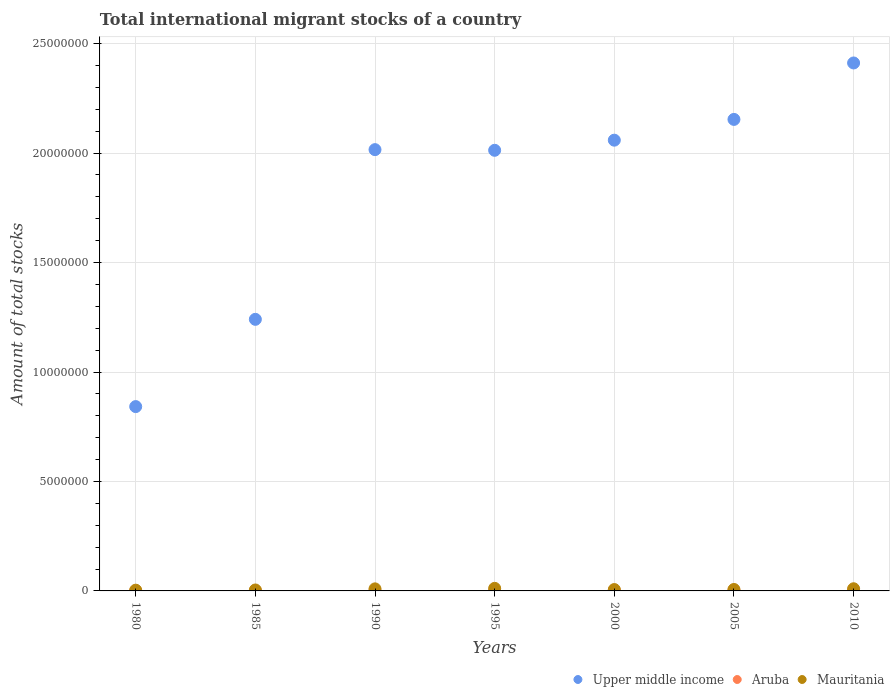Is the number of dotlines equal to the number of legend labels?
Provide a short and direct response. Yes. What is the amount of total stocks in in Aruba in 2010?
Offer a very short reply. 3.43e+04. Across all years, what is the maximum amount of total stocks in in Mauritania?
Give a very brief answer. 1.18e+05. Across all years, what is the minimum amount of total stocks in in Upper middle income?
Make the answer very short. 8.42e+06. In which year was the amount of total stocks in in Aruba minimum?
Keep it short and to the point. 1980. What is the total amount of total stocks in in Aruba in the graph?
Your response must be concise. 1.49e+05. What is the difference between the amount of total stocks in in Upper middle income in 1990 and that in 2000?
Offer a very short reply. -4.32e+05. What is the difference between the amount of total stocks in in Mauritania in 2000 and the amount of total stocks in in Aruba in 1980?
Your answer should be compact. 5.55e+04. What is the average amount of total stocks in in Aruba per year?
Provide a short and direct response. 2.13e+04. In the year 2000, what is the difference between the amount of total stocks in in Mauritania and amount of total stocks in in Aruba?
Provide a short and direct response. 3.31e+04. What is the ratio of the amount of total stocks in in Aruba in 1985 to that in 1990?
Keep it short and to the point. 0.68. Is the amount of total stocks in in Aruba in 1980 less than that in 1995?
Keep it short and to the point. Yes. Is the difference between the amount of total stocks in in Mauritania in 1985 and 1995 greater than the difference between the amount of total stocks in in Aruba in 1985 and 1995?
Provide a short and direct response. No. What is the difference between the highest and the second highest amount of total stocks in in Aruba?
Provide a succinct answer. 846. What is the difference between the highest and the lowest amount of total stocks in in Upper middle income?
Give a very brief answer. 1.57e+07. In how many years, is the amount of total stocks in in Aruba greater than the average amount of total stocks in in Aruba taken over all years?
Give a very brief answer. 3. Is it the case that in every year, the sum of the amount of total stocks in in Mauritania and amount of total stocks in in Upper middle income  is greater than the amount of total stocks in in Aruba?
Your answer should be compact. Yes. Does the amount of total stocks in in Aruba monotonically increase over the years?
Provide a short and direct response. Yes. Is the amount of total stocks in in Mauritania strictly greater than the amount of total stocks in in Upper middle income over the years?
Your answer should be compact. No. Is the amount of total stocks in in Aruba strictly less than the amount of total stocks in in Upper middle income over the years?
Give a very brief answer. Yes. How many dotlines are there?
Ensure brevity in your answer.  3. How many years are there in the graph?
Ensure brevity in your answer.  7. What is the difference between two consecutive major ticks on the Y-axis?
Ensure brevity in your answer.  5.00e+06. Are the values on the major ticks of Y-axis written in scientific E-notation?
Give a very brief answer. No. Does the graph contain any zero values?
Your answer should be compact. No. Does the graph contain grids?
Give a very brief answer. Yes. Where does the legend appear in the graph?
Offer a very short reply. Bottom right. What is the title of the graph?
Offer a very short reply. Total international migrant stocks of a country. Does "San Marino" appear as one of the legend labels in the graph?
Your response must be concise. No. What is the label or title of the Y-axis?
Offer a terse response. Amount of total stocks. What is the Amount of total stocks of Upper middle income in 1980?
Ensure brevity in your answer.  8.42e+06. What is the Amount of total stocks in Aruba in 1980?
Make the answer very short. 7063. What is the Amount of total stocks of Mauritania in 1980?
Offer a terse response. 3.37e+04. What is the Amount of total stocks in Upper middle income in 1985?
Keep it short and to the point. 1.24e+07. What is the Amount of total stocks of Aruba in 1985?
Keep it short and to the point. 9860. What is the Amount of total stocks in Mauritania in 1985?
Your answer should be very brief. 4.36e+04. What is the Amount of total stocks of Upper middle income in 1990?
Keep it short and to the point. 2.02e+07. What is the Amount of total stocks of Aruba in 1990?
Give a very brief answer. 1.44e+04. What is the Amount of total stocks in Mauritania in 1990?
Keep it short and to the point. 9.39e+04. What is the Amount of total stocks in Upper middle income in 1995?
Ensure brevity in your answer.  2.01e+07. What is the Amount of total stocks of Aruba in 1995?
Ensure brevity in your answer.  2.07e+04. What is the Amount of total stocks of Mauritania in 1995?
Provide a short and direct response. 1.18e+05. What is the Amount of total stocks in Upper middle income in 2000?
Provide a succinct answer. 2.06e+07. What is the Amount of total stocks in Aruba in 2000?
Provide a succinct answer. 2.95e+04. What is the Amount of total stocks of Mauritania in 2000?
Offer a very short reply. 6.26e+04. What is the Amount of total stocks of Upper middle income in 2005?
Provide a short and direct response. 2.15e+07. What is the Amount of total stocks in Aruba in 2005?
Your answer should be compact. 3.34e+04. What is the Amount of total stocks of Mauritania in 2005?
Provide a succinct answer. 6.61e+04. What is the Amount of total stocks in Upper middle income in 2010?
Keep it short and to the point. 2.41e+07. What is the Amount of total stocks of Aruba in 2010?
Offer a terse response. 3.43e+04. What is the Amount of total stocks of Mauritania in 2010?
Ensure brevity in your answer.  9.92e+04. Across all years, what is the maximum Amount of total stocks of Upper middle income?
Make the answer very short. 2.41e+07. Across all years, what is the maximum Amount of total stocks in Aruba?
Ensure brevity in your answer.  3.43e+04. Across all years, what is the maximum Amount of total stocks in Mauritania?
Make the answer very short. 1.18e+05. Across all years, what is the minimum Amount of total stocks of Upper middle income?
Provide a succinct answer. 8.42e+06. Across all years, what is the minimum Amount of total stocks of Aruba?
Your answer should be compact. 7063. Across all years, what is the minimum Amount of total stocks in Mauritania?
Keep it short and to the point. 3.37e+04. What is the total Amount of total stocks in Upper middle income in the graph?
Ensure brevity in your answer.  1.27e+08. What is the total Amount of total stocks in Aruba in the graph?
Keep it short and to the point. 1.49e+05. What is the total Amount of total stocks of Mauritania in the graph?
Make the answer very short. 5.17e+05. What is the difference between the Amount of total stocks of Upper middle income in 1980 and that in 1985?
Give a very brief answer. -3.99e+06. What is the difference between the Amount of total stocks in Aruba in 1980 and that in 1985?
Offer a very short reply. -2797. What is the difference between the Amount of total stocks in Mauritania in 1980 and that in 1985?
Your response must be concise. -9883. What is the difference between the Amount of total stocks of Upper middle income in 1980 and that in 1990?
Offer a very short reply. -1.17e+07. What is the difference between the Amount of total stocks of Aruba in 1980 and that in 1990?
Give a very brief answer. -7381. What is the difference between the Amount of total stocks in Mauritania in 1980 and that in 1990?
Your answer should be very brief. -6.02e+04. What is the difference between the Amount of total stocks in Upper middle income in 1980 and that in 1995?
Offer a very short reply. -1.17e+07. What is the difference between the Amount of total stocks in Aruba in 1980 and that in 1995?
Your response must be concise. -1.37e+04. What is the difference between the Amount of total stocks of Mauritania in 1980 and that in 1995?
Your response must be concise. -8.39e+04. What is the difference between the Amount of total stocks in Upper middle income in 1980 and that in 2000?
Provide a succinct answer. -1.22e+07. What is the difference between the Amount of total stocks in Aruba in 1980 and that in 2000?
Your answer should be very brief. -2.24e+04. What is the difference between the Amount of total stocks of Mauritania in 1980 and that in 2000?
Your answer should be compact. -2.89e+04. What is the difference between the Amount of total stocks of Upper middle income in 1980 and that in 2005?
Your answer should be very brief. -1.31e+07. What is the difference between the Amount of total stocks of Aruba in 1980 and that in 2005?
Your answer should be compact. -2.64e+04. What is the difference between the Amount of total stocks in Mauritania in 1980 and that in 2005?
Offer a terse response. -3.23e+04. What is the difference between the Amount of total stocks in Upper middle income in 1980 and that in 2010?
Ensure brevity in your answer.  -1.57e+07. What is the difference between the Amount of total stocks of Aruba in 1980 and that in 2010?
Make the answer very short. -2.72e+04. What is the difference between the Amount of total stocks of Mauritania in 1980 and that in 2010?
Make the answer very short. -6.55e+04. What is the difference between the Amount of total stocks of Upper middle income in 1985 and that in 1990?
Keep it short and to the point. -7.75e+06. What is the difference between the Amount of total stocks of Aruba in 1985 and that in 1990?
Offer a terse response. -4584. What is the difference between the Amount of total stocks in Mauritania in 1985 and that in 1990?
Your answer should be compact. -5.03e+04. What is the difference between the Amount of total stocks of Upper middle income in 1985 and that in 1995?
Offer a very short reply. -7.72e+06. What is the difference between the Amount of total stocks of Aruba in 1985 and that in 1995?
Provide a succinct answer. -1.09e+04. What is the difference between the Amount of total stocks in Mauritania in 1985 and that in 1995?
Give a very brief answer. -7.40e+04. What is the difference between the Amount of total stocks of Upper middle income in 1985 and that in 2000?
Your answer should be very brief. -8.18e+06. What is the difference between the Amount of total stocks of Aruba in 1985 and that in 2000?
Offer a terse response. -1.96e+04. What is the difference between the Amount of total stocks in Mauritania in 1985 and that in 2000?
Make the answer very short. -1.90e+04. What is the difference between the Amount of total stocks of Upper middle income in 1985 and that in 2005?
Your answer should be very brief. -9.13e+06. What is the difference between the Amount of total stocks of Aruba in 1985 and that in 2005?
Make the answer very short. -2.36e+04. What is the difference between the Amount of total stocks of Mauritania in 1985 and that in 2005?
Provide a succinct answer. -2.25e+04. What is the difference between the Amount of total stocks in Upper middle income in 1985 and that in 2010?
Offer a terse response. -1.17e+07. What is the difference between the Amount of total stocks in Aruba in 1985 and that in 2010?
Keep it short and to the point. -2.44e+04. What is the difference between the Amount of total stocks in Mauritania in 1985 and that in 2010?
Your response must be concise. -5.56e+04. What is the difference between the Amount of total stocks in Upper middle income in 1990 and that in 1995?
Your answer should be compact. 3.02e+04. What is the difference between the Amount of total stocks in Aruba in 1990 and that in 1995?
Your answer should be compact. -6271. What is the difference between the Amount of total stocks in Mauritania in 1990 and that in 1995?
Provide a short and direct response. -2.37e+04. What is the difference between the Amount of total stocks in Upper middle income in 1990 and that in 2000?
Ensure brevity in your answer.  -4.32e+05. What is the difference between the Amount of total stocks of Aruba in 1990 and that in 2000?
Your answer should be compact. -1.51e+04. What is the difference between the Amount of total stocks in Mauritania in 1990 and that in 2000?
Provide a succinct answer. 3.13e+04. What is the difference between the Amount of total stocks in Upper middle income in 1990 and that in 2005?
Offer a terse response. -1.38e+06. What is the difference between the Amount of total stocks of Aruba in 1990 and that in 2005?
Your response must be concise. -1.90e+04. What is the difference between the Amount of total stocks in Mauritania in 1990 and that in 2005?
Provide a short and direct response. 2.78e+04. What is the difference between the Amount of total stocks of Upper middle income in 1990 and that in 2010?
Make the answer very short. -3.96e+06. What is the difference between the Amount of total stocks of Aruba in 1990 and that in 2010?
Ensure brevity in your answer.  -1.98e+04. What is the difference between the Amount of total stocks in Mauritania in 1990 and that in 2010?
Offer a terse response. -5351. What is the difference between the Amount of total stocks in Upper middle income in 1995 and that in 2000?
Give a very brief answer. -4.63e+05. What is the difference between the Amount of total stocks in Aruba in 1995 and that in 2000?
Ensure brevity in your answer.  -8780. What is the difference between the Amount of total stocks in Mauritania in 1995 and that in 2000?
Offer a very short reply. 5.50e+04. What is the difference between the Amount of total stocks of Upper middle income in 1995 and that in 2005?
Keep it short and to the point. -1.41e+06. What is the difference between the Amount of total stocks of Aruba in 1995 and that in 2005?
Provide a succinct answer. -1.27e+04. What is the difference between the Amount of total stocks in Mauritania in 1995 and that in 2005?
Your answer should be very brief. 5.15e+04. What is the difference between the Amount of total stocks in Upper middle income in 1995 and that in 2010?
Your answer should be very brief. -3.99e+06. What is the difference between the Amount of total stocks of Aruba in 1995 and that in 2010?
Offer a very short reply. -1.36e+04. What is the difference between the Amount of total stocks in Mauritania in 1995 and that in 2010?
Ensure brevity in your answer.  1.84e+04. What is the difference between the Amount of total stocks of Upper middle income in 2000 and that in 2005?
Offer a very short reply. -9.49e+05. What is the difference between the Amount of total stocks in Aruba in 2000 and that in 2005?
Offer a terse response. -3927. What is the difference between the Amount of total stocks of Mauritania in 2000 and that in 2005?
Make the answer very short. -3460. What is the difference between the Amount of total stocks in Upper middle income in 2000 and that in 2010?
Offer a terse response. -3.53e+06. What is the difference between the Amount of total stocks in Aruba in 2000 and that in 2010?
Your answer should be compact. -4773. What is the difference between the Amount of total stocks in Mauritania in 2000 and that in 2010?
Make the answer very short. -3.66e+04. What is the difference between the Amount of total stocks in Upper middle income in 2005 and that in 2010?
Ensure brevity in your answer.  -2.58e+06. What is the difference between the Amount of total stocks in Aruba in 2005 and that in 2010?
Make the answer very short. -846. What is the difference between the Amount of total stocks in Mauritania in 2005 and that in 2010?
Your response must be concise. -3.32e+04. What is the difference between the Amount of total stocks in Upper middle income in 1980 and the Amount of total stocks in Aruba in 1985?
Your answer should be compact. 8.41e+06. What is the difference between the Amount of total stocks in Upper middle income in 1980 and the Amount of total stocks in Mauritania in 1985?
Your answer should be very brief. 8.38e+06. What is the difference between the Amount of total stocks of Aruba in 1980 and the Amount of total stocks of Mauritania in 1985?
Offer a terse response. -3.65e+04. What is the difference between the Amount of total stocks of Upper middle income in 1980 and the Amount of total stocks of Aruba in 1990?
Your answer should be very brief. 8.41e+06. What is the difference between the Amount of total stocks of Upper middle income in 1980 and the Amount of total stocks of Mauritania in 1990?
Keep it short and to the point. 8.33e+06. What is the difference between the Amount of total stocks in Aruba in 1980 and the Amount of total stocks in Mauritania in 1990?
Keep it short and to the point. -8.68e+04. What is the difference between the Amount of total stocks in Upper middle income in 1980 and the Amount of total stocks in Aruba in 1995?
Give a very brief answer. 8.40e+06. What is the difference between the Amount of total stocks of Upper middle income in 1980 and the Amount of total stocks of Mauritania in 1995?
Provide a short and direct response. 8.30e+06. What is the difference between the Amount of total stocks in Aruba in 1980 and the Amount of total stocks in Mauritania in 1995?
Make the answer very short. -1.11e+05. What is the difference between the Amount of total stocks in Upper middle income in 1980 and the Amount of total stocks in Aruba in 2000?
Make the answer very short. 8.39e+06. What is the difference between the Amount of total stocks of Upper middle income in 1980 and the Amount of total stocks of Mauritania in 2000?
Offer a very short reply. 8.36e+06. What is the difference between the Amount of total stocks in Aruba in 1980 and the Amount of total stocks in Mauritania in 2000?
Your response must be concise. -5.55e+04. What is the difference between the Amount of total stocks in Upper middle income in 1980 and the Amount of total stocks in Aruba in 2005?
Make the answer very short. 8.39e+06. What is the difference between the Amount of total stocks of Upper middle income in 1980 and the Amount of total stocks of Mauritania in 2005?
Keep it short and to the point. 8.35e+06. What is the difference between the Amount of total stocks in Aruba in 1980 and the Amount of total stocks in Mauritania in 2005?
Offer a terse response. -5.90e+04. What is the difference between the Amount of total stocks of Upper middle income in 1980 and the Amount of total stocks of Aruba in 2010?
Make the answer very short. 8.39e+06. What is the difference between the Amount of total stocks in Upper middle income in 1980 and the Amount of total stocks in Mauritania in 2010?
Offer a very short reply. 8.32e+06. What is the difference between the Amount of total stocks in Aruba in 1980 and the Amount of total stocks in Mauritania in 2010?
Provide a succinct answer. -9.22e+04. What is the difference between the Amount of total stocks of Upper middle income in 1985 and the Amount of total stocks of Aruba in 1990?
Offer a very short reply. 1.24e+07. What is the difference between the Amount of total stocks of Upper middle income in 1985 and the Amount of total stocks of Mauritania in 1990?
Your answer should be compact. 1.23e+07. What is the difference between the Amount of total stocks of Aruba in 1985 and the Amount of total stocks of Mauritania in 1990?
Offer a terse response. -8.40e+04. What is the difference between the Amount of total stocks in Upper middle income in 1985 and the Amount of total stocks in Aruba in 1995?
Your answer should be compact. 1.24e+07. What is the difference between the Amount of total stocks of Upper middle income in 1985 and the Amount of total stocks of Mauritania in 1995?
Provide a succinct answer. 1.23e+07. What is the difference between the Amount of total stocks in Aruba in 1985 and the Amount of total stocks in Mauritania in 1995?
Your answer should be compact. -1.08e+05. What is the difference between the Amount of total stocks in Upper middle income in 1985 and the Amount of total stocks in Aruba in 2000?
Ensure brevity in your answer.  1.24e+07. What is the difference between the Amount of total stocks in Upper middle income in 1985 and the Amount of total stocks in Mauritania in 2000?
Your response must be concise. 1.23e+07. What is the difference between the Amount of total stocks of Aruba in 1985 and the Amount of total stocks of Mauritania in 2000?
Offer a terse response. -5.27e+04. What is the difference between the Amount of total stocks in Upper middle income in 1985 and the Amount of total stocks in Aruba in 2005?
Give a very brief answer. 1.24e+07. What is the difference between the Amount of total stocks of Upper middle income in 1985 and the Amount of total stocks of Mauritania in 2005?
Give a very brief answer. 1.23e+07. What is the difference between the Amount of total stocks in Aruba in 1985 and the Amount of total stocks in Mauritania in 2005?
Provide a short and direct response. -5.62e+04. What is the difference between the Amount of total stocks of Upper middle income in 1985 and the Amount of total stocks of Aruba in 2010?
Give a very brief answer. 1.24e+07. What is the difference between the Amount of total stocks in Upper middle income in 1985 and the Amount of total stocks in Mauritania in 2010?
Make the answer very short. 1.23e+07. What is the difference between the Amount of total stocks of Aruba in 1985 and the Amount of total stocks of Mauritania in 2010?
Provide a short and direct response. -8.94e+04. What is the difference between the Amount of total stocks of Upper middle income in 1990 and the Amount of total stocks of Aruba in 1995?
Your answer should be very brief. 2.01e+07. What is the difference between the Amount of total stocks in Upper middle income in 1990 and the Amount of total stocks in Mauritania in 1995?
Ensure brevity in your answer.  2.00e+07. What is the difference between the Amount of total stocks in Aruba in 1990 and the Amount of total stocks in Mauritania in 1995?
Keep it short and to the point. -1.03e+05. What is the difference between the Amount of total stocks of Upper middle income in 1990 and the Amount of total stocks of Aruba in 2000?
Keep it short and to the point. 2.01e+07. What is the difference between the Amount of total stocks in Upper middle income in 1990 and the Amount of total stocks in Mauritania in 2000?
Make the answer very short. 2.01e+07. What is the difference between the Amount of total stocks of Aruba in 1990 and the Amount of total stocks of Mauritania in 2000?
Offer a terse response. -4.81e+04. What is the difference between the Amount of total stocks in Upper middle income in 1990 and the Amount of total stocks in Aruba in 2005?
Offer a terse response. 2.01e+07. What is the difference between the Amount of total stocks of Upper middle income in 1990 and the Amount of total stocks of Mauritania in 2005?
Give a very brief answer. 2.01e+07. What is the difference between the Amount of total stocks in Aruba in 1990 and the Amount of total stocks in Mauritania in 2005?
Your answer should be compact. -5.16e+04. What is the difference between the Amount of total stocks of Upper middle income in 1990 and the Amount of total stocks of Aruba in 2010?
Make the answer very short. 2.01e+07. What is the difference between the Amount of total stocks in Upper middle income in 1990 and the Amount of total stocks in Mauritania in 2010?
Offer a very short reply. 2.01e+07. What is the difference between the Amount of total stocks in Aruba in 1990 and the Amount of total stocks in Mauritania in 2010?
Make the answer very short. -8.48e+04. What is the difference between the Amount of total stocks in Upper middle income in 1995 and the Amount of total stocks in Aruba in 2000?
Provide a short and direct response. 2.01e+07. What is the difference between the Amount of total stocks in Upper middle income in 1995 and the Amount of total stocks in Mauritania in 2000?
Your answer should be very brief. 2.01e+07. What is the difference between the Amount of total stocks of Aruba in 1995 and the Amount of total stocks of Mauritania in 2000?
Your answer should be very brief. -4.19e+04. What is the difference between the Amount of total stocks in Upper middle income in 1995 and the Amount of total stocks in Aruba in 2005?
Offer a terse response. 2.01e+07. What is the difference between the Amount of total stocks of Upper middle income in 1995 and the Amount of total stocks of Mauritania in 2005?
Ensure brevity in your answer.  2.01e+07. What is the difference between the Amount of total stocks of Aruba in 1995 and the Amount of total stocks of Mauritania in 2005?
Provide a short and direct response. -4.53e+04. What is the difference between the Amount of total stocks of Upper middle income in 1995 and the Amount of total stocks of Aruba in 2010?
Provide a succinct answer. 2.01e+07. What is the difference between the Amount of total stocks in Upper middle income in 1995 and the Amount of total stocks in Mauritania in 2010?
Provide a succinct answer. 2.00e+07. What is the difference between the Amount of total stocks of Aruba in 1995 and the Amount of total stocks of Mauritania in 2010?
Make the answer very short. -7.85e+04. What is the difference between the Amount of total stocks in Upper middle income in 2000 and the Amount of total stocks in Aruba in 2005?
Ensure brevity in your answer.  2.06e+07. What is the difference between the Amount of total stocks in Upper middle income in 2000 and the Amount of total stocks in Mauritania in 2005?
Offer a terse response. 2.05e+07. What is the difference between the Amount of total stocks in Aruba in 2000 and the Amount of total stocks in Mauritania in 2005?
Provide a short and direct response. -3.66e+04. What is the difference between the Amount of total stocks in Upper middle income in 2000 and the Amount of total stocks in Aruba in 2010?
Your answer should be very brief. 2.06e+07. What is the difference between the Amount of total stocks in Upper middle income in 2000 and the Amount of total stocks in Mauritania in 2010?
Provide a succinct answer. 2.05e+07. What is the difference between the Amount of total stocks of Aruba in 2000 and the Amount of total stocks of Mauritania in 2010?
Keep it short and to the point. -6.97e+04. What is the difference between the Amount of total stocks in Upper middle income in 2005 and the Amount of total stocks in Aruba in 2010?
Provide a short and direct response. 2.15e+07. What is the difference between the Amount of total stocks of Upper middle income in 2005 and the Amount of total stocks of Mauritania in 2010?
Give a very brief answer. 2.14e+07. What is the difference between the Amount of total stocks in Aruba in 2005 and the Amount of total stocks in Mauritania in 2010?
Provide a succinct answer. -6.58e+04. What is the average Amount of total stocks in Upper middle income per year?
Provide a short and direct response. 1.82e+07. What is the average Amount of total stocks of Aruba per year?
Offer a terse response. 2.13e+04. What is the average Amount of total stocks of Mauritania per year?
Your answer should be very brief. 7.38e+04. In the year 1980, what is the difference between the Amount of total stocks of Upper middle income and Amount of total stocks of Aruba?
Provide a succinct answer. 8.41e+06. In the year 1980, what is the difference between the Amount of total stocks of Upper middle income and Amount of total stocks of Mauritania?
Your answer should be compact. 8.39e+06. In the year 1980, what is the difference between the Amount of total stocks in Aruba and Amount of total stocks in Mauritania?
Provide a succinct answer. -2.67e+04. In the year 1985, what is the difference between the Amount of total stocks in Upper middle income and Amount of total stocks in Aruba?
Your answer should be compact. 1.24e+07. In the year 1985, what is the difference between the Amount of total stocks in Upper middle income and Amount of total stocks in Mauritania?
Your answer should be very brief. 1.24e+07. In the year 1985, what is the difference between the Amount of total stocks of Aruba and Amount of total stocks of Mauritania?
Your response must be concise. -3.37e+04. In the year 1990, what is the difference between the Amount of total stocks of Upper middle income and Amount of total stocks of Aruba?
Provide a succinct answer. 2.01e+07. In the year 1990, what is the difference between the Amount of total stocks in Upper middle income and Amount of total stocks in Mauritania?
Your answer should be compact. 2.01e+07. In the year 1990, what is the difference between the Amount of total stocks in Aruba and Amount of total stocks in Mauritania?
Keep it short and to the point. -7.94e+04. In the year 1995, what is the difference between the Amount of total stocks in Upper middle income and Amount of total stocks in Aruba?
Provide a short and direct response. 2.01e+07. In the year 1995, what is the difference between the Amount of total stocks in Upper middle income and Amount of total stocks in Mauritania?
Keep it short and to the point. 2.00e+07. In the year 1995, what is the difference between the Amount of total stocks in Aruba and Amount of total stocks in Mauritania?
Provide a succinct answer. -9.69e+04. In the year 2000, what is the difference between the Amount of total stocks of Upper middle income and Amount of total stocks of Aruba?
Offer a very short reply. 2.06e+07. In the year 2000, what is the difference between the Amount of total stocks in Upper middle income and Amount of total stocks in Mauritania?
Ensure brevity in your answer.  2.05e+07. In the year 2000, what is the difference between the Amount of total stocks in Aruba and Amount of total stocks in Mauritania?
Make the answer very short. -3.31e+04. In the year 2005, what is the difference between the Amount of total stocks in Upper middle income and Amount of total stocks in Aruba?
Make the answer very short. 2.15e+07. In the year 2005, what is the difference between the Amount of total stocks in Upper middle income and Amount of total stocks in Mauritania?
Offer a terse response. 2.15e+07. In the year 2005, what is the difference between the Amount of total stocks in Aruba and Amount of total stocks in Mauritania?
Ensure brevity in your answer.  -3.26e+04. In the year 2010, what is the difference between the Amount of total stocks of Upper middle income and Amount of total stocks of Aruba?
Make the answer very short. 2.41e+07. In the year 2010, what is the difference between the Amount of total stocks of Upper middle income and Amount of total stocks of Mauritania?
Offer a very short reply. 2.40e+07. In the year 2010, what is the difference between the Amount of total stocks in Aruba and Amount of total stocks in Mauritania?
Offer a terse response. -6.50e+04. What is the ratio of the Amount of total stocks in Upper middle income in 1980 to that in 1985?
Your answer should be very brief. 0.68. What is the ratio of the Amount of total stocks in Aruba in 1980 to that in 1985?
Make the answer very short. 0.72. What is the ratio of the Amount of total stocks of Mauritania in 1980 to that in 1985?
Ensure brevity in your answer.  0.77. What is the ratio of the Amount of total stocks in Upper middle income in 1980 to that in 1990?
Offer a terse response. 0.42. What is the ratio of the Amount of total stocks in Aruba in 1980 to that in 1990?
Give a very brief answer. 0.49. What is the ratio of the Amount of total stocks of Mauritania in 1980 to that in 1990?
Make the answer very short. 0.36. What is the ratio of the Amount of total stocks of Upper middle income in 1980 to that in 1995?
Your answer should be very brief. 0.42. What is the ratio of the Amount of total stocks of Aruba in 1980 to that in 1995?
Your answer should be very brief. 0.34. What is the ratio of the Amount of total stocks in Mauritania in 1980 to that in 1995?
Ensure brevity in your answer.  0.29. What is the ratio of the Amount of total stocks of Upper middle income in 1980 to that in 2000?
Ensure brevity in your answer.  0.41. What is the ratio of the Amount of total stocks of Aruba in 1980 to that in 2000?
Give a very brief answer. 0.24. What is the ratio of the Amount of total stocks in Mauritania in 1980 to that in 2000?
Keep it short and to the point. 0.54. What is the ratio of the Amount of total stocks of Upper middle income in 1980 to that in 2005?
Your answer should be very brief. 0.39. What is the ratio of the Amount of total stocks of Aruba in 1980 to that in 2005?
Give a very brief answer. 0.21. What is the ratio of the Amount of total stocks in Mauritania in 1980 to that in 2005?
Your response must be concise. 0.51. What is the ratio of the Amount of total stocks of Upper middle income in 1980 to that in 2010?
Ensure brevity in your answer.  0.35. What is the ratio of the Amount of total stocks in Aruba in 1980 to that in 2010?
Provide a short and direct response. 0.21. What is the ratio of the Amount of total stocks of Mauritania in 1980 to that in 2010?
Keep it short and to the point. 0.34. What is the ratio of the Amount of total stocks in Upper middle income in 1985 to that in 1990?
Keep it short and to the point. 0.62. What is the ratio of the Amount of total stocks in Aruba in 1985 to that in 1990?
Keep it short and to the point. 0.68. What is the ratio of the Amount of total stocks in Mauritania in 1985 to that in 1990?
Give a very brief answer. 0.46. What is the ratio of the Amount of total stocks of Upper middle income in 1985 to that in 1995?
Offer a terse response. 0.62. What is the ratio of the Amount of total stocks in Aruba in 1985 to that in 1995?
Make the answer very short. 0.48. What is the ratio of the Amount of total stocks of Mauritania in 1985 to that in 1995?
Give a very brief answer. 0.37. What is the ratio of the Amount of total stocks in Upper middle income in 1985 to that in 2000?
Ensure brevity in your answer.  0.6. What is the ratio of the Amount of total stocks of Aruba in 1985 to that in 2000?
Offer a terse response. 0.33. What is the ratio of the Amount of total stocks of Mauritania in 1985 to that in 2000?
Make the answer very short. 0.7. What is the ratio of the Amount of total stocks in Upper middle income in 1985 to that in 2005?
Ensure brevity in your answer.  0.58. What is the ratio of the Amount of total stocks of Aruba in 1985 to that in 2005?
Your response must be concise. 0.29. What is the ratio of the Amount of total stocks in Mauritania in 1985 to that in 2005?
Keep it short and to the point. 0.66. What is the ratio of the Amount of total stocks in Upper middle income in 1985 to that in 2010?
Your answer should be compact. 0.51. What is the ratio of the Amount of total stocks of Aruba in 1985 to that in 2010?
Keep it short and to the point. 0.29. What is the ratio of the Amount of total stocks of Mauritania in 1985 to that in 2010?
Provide a succinct answer. 0.44. What is the ratio of the Amount of total stocks in Upper middle income in 1990 to that in 1995?
Provide a succinct answer. 1. What is the ratio of the Amount of total stocks of Aruba in 1990 to that in 1995?
Your answer should be very brief. 0.7. What is the ratio of the Amount of total stocks of Mauritania in 1990 to that in 1995?
Make the answer very short. 0.8. What is the ratio of the Amount of total stocks of Upper middle income in 1990 to that in 2000?
Provide a succinct answer. 0.98. What is the ratio of the Amount of total stocks of Aruba in 1990 to that in 2000?
Offer a very short reply. 0.49. What is the ratio of the Amount of total stocks of Mauritania in 1990 to that in 2000?
Offer a terse response. 1.5. What is the ratio of the Amount of total stocks of Upper middle income in 1990 to that in 2005?
Make the answer very short. 0.94. What is the ratio of the Amount of total stocks of Aruba in 1990 to that in 2005?
Provide a succinct answer. 0.43. What is the ratio of the Amount of total stocks in Mauritania in 1990 to that in 2005?
Ensure brevity in your answer.  1.42. What is the ratio of the Amount of total stocks in Upper middle income in 1990 to that in 2010?
Keep it short and to the point. 0.84. What is the ratio of the Amount of total stocks in Aruba in 1990 to that in 2010?
Give a very brief answer. 0.42. What is the ratio of the Amount of total stocks of Mauritania in 1990 to that in 2010?
Your response must be concise. 0.95. What is the ratio of the Amount of total stocks of Upper middle income in 1995 to that in 2000?
Your answer should be very brief. 0.98. What is the ratio of the Amount of total stocks of Aruba in 1995 to that in 2000?
Keep it short and to the point. 0.7. What is the ratio of the Amount of total stocks in Mauritania in 1995 to that in 2000?
Keep it short and to the point. 1.88. What is the ratio of the Amount of total stocks of Upper middle income in 1995 to that in 2005?
Your response must be concise. 0.93. What is the ratio of the Amount of total stocks of Aruba in 1995 to that in 2005?
Offer a very short reply. 0.62. What is the ratio of the Amount of total stocks of Mauritania in 1995 to that in 2005?
Your response must be concise. 1.78. What is the ratio of the Amount of total stocks in Upper middle income in 1995 to that in 2010?
Ensure brevity in your answer.  0.83. What is the ratio of the Amount of total stocks in Aruba in 1995 to that in 2010?
Make the answer very short. 0.6. What is the ratio of the Amount of total stocks of Mauritania in 1995 to that in 2010?
Make the answer very short. 1.18. What is the ratio of the Amount of total stocks in Upper middle income in 2000 to that in 2005?
Ensure brevity in your answer.  0.96. What is the ratio of the Amount of total stocks of Aruba in 2000 to that in 2005?
Offer a very short reply. 0.88. What is the ratio of the Amount of total stocks in Mauritania in 2000 to that in 2005?
Your answer should be compact. 0.95. What is the ratio of the Amount of total stocks in Upper middle income in 2000 to that in 2010?
Make the answer very short. 0.85. What is the ratio of the Amount of total stocks in Aruba in 2000 to that in 2010?
Ensure brevity in your answer.  0.86. What is the ratio of the Amount of total stocks of Mauritania in 2000 to that in 2010?
Provide a short and direct response. 0.63. What is the ratio of the Amount of total stocks of Upper middle income in 2005 to that in 2010?
Ensure brevity in your answer.  0.89. What is the ratio of the Amount of total stocks in Aruba in 2005 to that in 2010?
Ensure brevity in your answer.  0.98. What is the ratio of the Amount of total stocks of Mauritania in 2005 to that in 2010?
Give a very brief answer. 0.67. What is the difference between the highest and the second highest Amount of total stocks in Upper middle income?
Make the answer very short. 2.58e+06. What is the difference between the highest and the second highest Amount of total stocks of Aruba?
Ensure brevity in your answer.  846. What is the difference between the highest and the second highest Amount of total stocks of Mauritania?
Provide a short and direct response. 1.84e+04. What is the difference between the highest and the lowest Amount of total stocks in Upper middle income?
Provide a short and direct response. 1.57e+07. What is the difference between the highest and the lowest Amount of total stocks in Aruba?
Provide a short and direct response. 2.72e+04. What is the difference between the highest and the lowest Amount of total stocks of Mauritania?
Your answer should be very brief. 8.39e+04. 